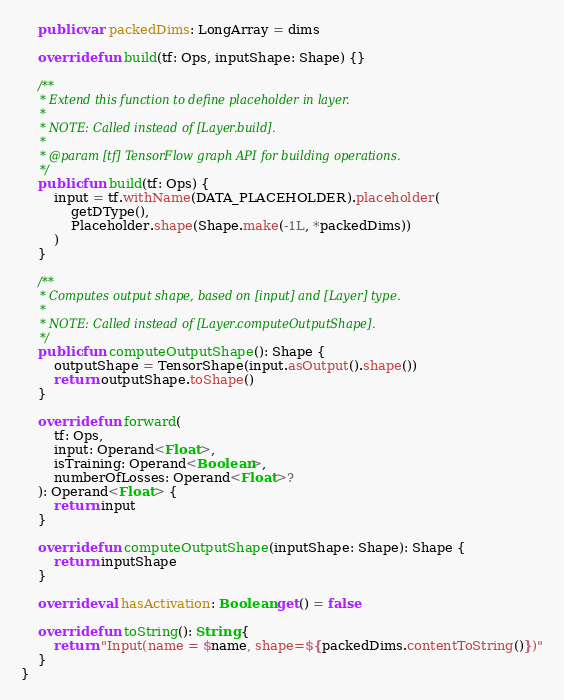<code> <loc_0><loc_0><loc_500><loc_500><_Kotlin_>    public var packedDims: LongArray = dims

    override fun build(tf: Ops, inputShape: Shape) {}

    /**
     * Extend this function to define placeholder in layer.
     *
     * NOTE: Called instead of [Layer.build].
     *
     * @param [tf] TensorFlow graph API for building operations.
     */
    public fun build(tf: Ops) {
        input = tf.withName(DATA_PLACEHOLDER).placeholder(
            getDType(),
            Placeholder.shape(Shape.make(-1L, *packedDims))
        )
    }

    /**
     * Computes output shape, based on [input] and [Layer] type.
     *
     * NOTE: Called instead of [Layer.computeOutputShape].
     */
    public fun computeOutputShape(): Shape {
        outputShape = TensorShape(input.asOutput().shape())
        return outputShape.toShape()
    }

    override fun forward(
        tf: Ops,
        input: Operand<Float>,
        isTraining: Operand<Boolean>,
        numberOfLosses: Operand<Float>?
    ): Operand<Float> {
        return input
    }

    override fun computeOutputShape(inputShape: Shape): Shape {
        return inputShape
    }

    override val hasActivation: Boolean get() = false

    override fun toString(): String {
        return "Input(name = $name, shape=${packedDims.contentToString()})"
    }
}
</code> 